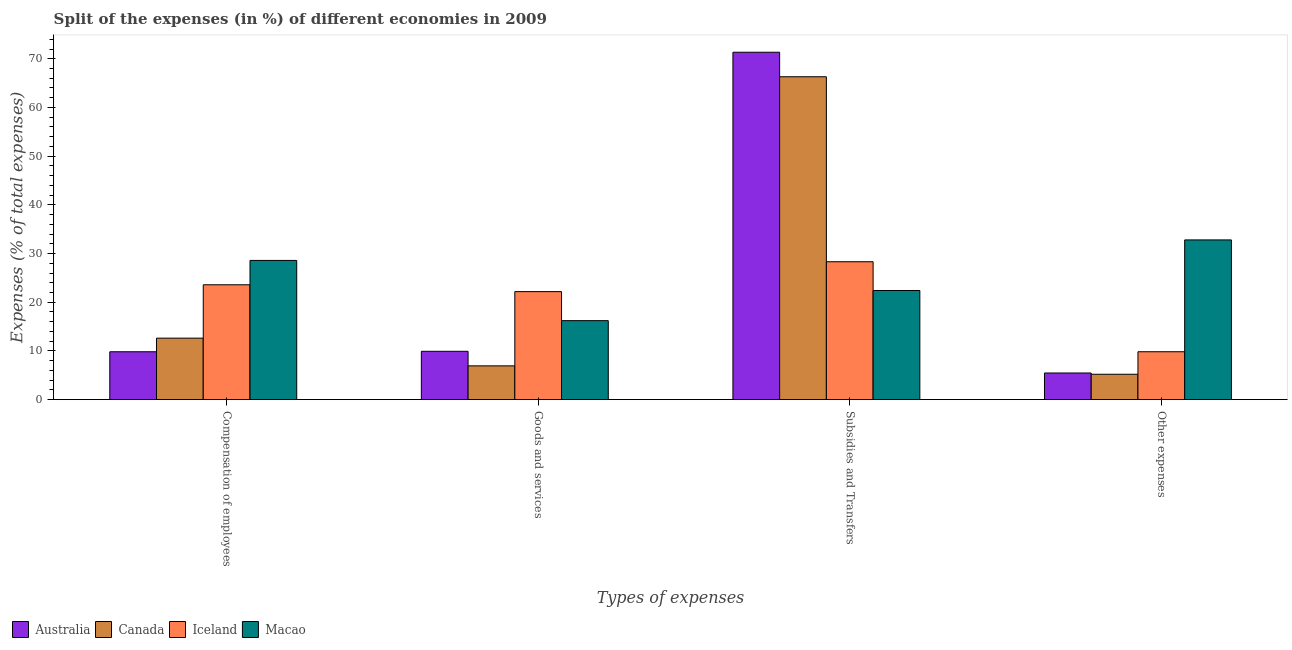How many different coloured bars are there?
Your answer should be very brief. 4. How many groups of bars are there?
Give a very brief answer. 4. Are the number of bars per tick equal to the number of legend labels?
Provide a short and direct response. Yes. Are the number of bars on each tick of the X-axis equal?
Provide a short and direct response. Yes. How many bars are there on the 2nd tick from the right?
Ensure brevity in your answer.  4. What is the label of the 4th group of bars from the left?
Provide a succinct answer. Other expenses. What is the percentage of amount spent on subsidies in Australia?
Offer a very short reply. 71.34. Across all countries, what is the maximum percentage of amount spent on compensation of employees?
Make the answer very short. 28.58. Across all countries, what is the minimum percentage of amount spent on subsidies?
Your answer should be very brief. 22.41. What is the total percentage of amount spent on other expenses in the graph?
Offer a very short reply. 53.3. What is the difference between the percentage of amount spent on goods and services in Iceland and that in Macao?
Provide a succinct answer. 5.96. What is the difference between the percentage of amount spent on compensation of employees in Iceland and the percentage of amount spent on other expenses in Macao?
Make the answer very short. -9.21. What is the average percentage of amount spent on compensation of employees per country?
Provide a short and direct response. 18.65. What is the difference between the percentage of amount spent on compensation of employees and percentage of amount spent on other expenses in Canada?
Keep it short and to the point. 7.42. In how many countries, is the percentage of amount spent on goods and services greater than 12 %?
Provide a short and direct response. 2. What is the ratio of the percentage of amount spent on other expenses in Canada to that in Australia?
Your response must be concise. 0.95. Is the percentage of amount spent on subsidies in Australia less than that in Canada?
Offer a terse response. No. Is the difference between the percentage of amount spent on compensation of employees in Iceland and Canada greater than the difference between the percentage of amount spent on other expenses in Iceland and Canada?
Give a very brief answer. Yes. What is the difference between the highest and the second highest percentage of amount spent on goods and services?
Provide a succinct answer. 5.96. What is the difference between the highest and the lowest percentage of amount spent on goods and services?
Provide a succinct answer. 15.25. In how many countries, is the percentage of amount spent on subsidies greater than the average percentage of amount spent on subsidies taken over all countries?
Make the answer very short. 2. Is it the case that in every country, the sum of the percentage of amount spent on compensation of employees and percentage of amount spent on subsidies is greater than the sum of percentage of amount spent on other expenses and percentage of amount spent on goods and services?
Ensure brevity in your answer.  Yes. Is it the case that in every country, the sum of the percentage of amount spent on compensation of employees and percentage of amount spent on goods and services is greater than the percentage of amount spent on subsidies?
Give a very brief answer. No. Are all the bars in the graph horizontal?
Give a very brief answer. No. Are the values on the major ticks of Y-axis written in scientific E-notation?
Make the answer very short. No. Does the graph contain grids?
Ensure brevity in your answer.  No. How many legend labels are there?
Keep it short and to the point. 4. What is the title of the graph?
Your answer should be very brief. Split of the expenses (in %) of different economies in 2009. What is the label or title of the X-axis?
Your response must be concise. Types of expenses. What is the label or title of the Y-axis?
Provide a short and direct response. Expenses (% of total expenses). What is the Expenses (% of total expenses) in Australia in Compensation of employees?
Ensure brevity in your answer.  9.83. What is the Expenses (% of total expenses) of Canada in Compensation of employees?
Keep it short and to the point. 12.62. What is the Expenses (% of total expenses) in Iceland in Compensation of employees?
Provide a short and direct response. 23.58. What is the Expenses (% of total expenses) in Macao in Compensation of employees?
Your answer should be very brief. 28.58. What is the Expenses (% of total expenses) of Australia in Goods and services?
Keep it short and to the point. 9.92. What is the Expenses (% of total expenses) of Canada in Goods and services?
Keep it short and to the point. 6.93. What is the Expenses (% of total expenses) in Iceland in Goods and services?
Offer a terse response. 22.18. What is the Expenses (% of total expenses) in Macao in Goods and services?
Provide a short and direct response. 16.21. What is the Expenses (% of total expenses) of Australia in Subsidies and Transfers?
Your answer should be compact. 71.34. What is the Expenses (% of total expenses) of Canada in Subsidies and Transfers?
Your answer should be compact. 66.3. What is the Expenses (% of total expenses) of Iceland in Subsidies and Transfers?
Your answer should be very brief. 28.31. What is the Expenses (% of total expenses) of Macao in Subsidies and Transfers?
Provide a short and direct response. 22.41. What is the Expenses (% of total expenses) in Australia in Other expenses?
Your response must be concise. 5.47. What is the Expenses (% of total expenses) in Canada in Other expenses?
Your answer should be very brief. 5.2. What is the Expenses (% of total expenses) of Iceland in Other expenses?
Your response must be concise. 9.83. What is the Expenses (% of total expenses) of Macao in Other expenses?
Your answer should be very brief. 32.8. Across all Types of expenses, what is the maximum Expenses (% of total expenses) in Australia?
Provide a succinct answer. 71.34. Across all Types of expenses, what is the maximum Expenses (% of total expenses) of Canada?
Keep it short and to the point. 66.3. Across all Types of expenses, what is the maximum Expenses (% of total expenses) of Iceland?
Offer a terse response. 28.31. Across all Types of expenses, what is the maximum Expenses (% of total expenses) of Macao?
Make the answer very short. 32.8. Across all Types of expenses, what is the minimum Expenses (% of total expenses) of Australia?
Keep it short and to the point. 5.47. Across all Types of expenses, what is the minimum Expenses (% of total expenses) of Canada?
Ensure brevity in your answer.  5.2. Across all Types of expenses, what is the minimum Expenses (% of total expenses) of Iceland?
Provide a short and direct response. 9.83. Across all Types of expenses, what is the minimum Expenses (% of total expenses) in Macao?
Ensure brevity in your answer.  16.21. What is the total Expenses (% of total expenses) in Australia in the graph?
Your response must be concise. 96.55. What is the total Expenses (% of total expenses) of Canada in the graph?
Your answer should be compact. 91.06. What is the total Expenses (% of total expenses) of Iceland in the graph?
Offer a very short reply. 83.91. What is the total Expenses (% of total expenses) in Macao in the graph?
Make the answer very short. 100. What is the difference between the Expenses (% of total expenses) in Australia in Compensation of employees and that in Goods and services?
Offer a terse response. -0.09. What is the difference between the Expenses (% of total expenses) of Canada in Compensation of employees and that in Goods and services?
Offer a terse response. 5.69. What is the difference between the Expenses (% of total expenses) of Iceland in Compensation of employees and that in Goods and services?
Make the answer very short. 1.41. What is the difference between the Expenses (% of total expenses) in Macao in Compensation of employees and that in Goods and services?
Offer a terse response. 12.37. What is the difference between the Expenses (% of total expenses) of Australia in Compensation of employees and that in Subsidies and Transfers?
Provide a short and direct response. -61.51. What is the difference between the Expenses (% of total expenses) in Canada in Compensation of employees and that in Subsidies and Transfers?
Your response must be concise. -53.68. What is the difference between the Expenses (% of total expenses) of Iceland in Compensation of employees and that in Subsidies and Transfers?
Provide a short and direct response. -4.73. What is the difference between the Expenses (% of total expenses) of Macao in Compensation of employees and that in Subsidies and Transfers?
Provide a short and direct response. 6.17. What is the difference between the Expenses (% of total expenses) of Australia in Compensation of employees and that in Other expenses?
Provide a succinct answer. 4.36. What is the difference between the Expenses (% of total expenses) of Canada in Compensation of employees and that in Other expenses?
Your answer should be compact. 7.42. What is the difference between the Expenses (% of total expenses) of Iceland in Compensation of employees and that in Other expenses?
Offer a very short reply. 13.75. What is the difference between the Expenses (% of total expenses) in Macao in Compensation of employees and that in Other expenses?
Provide a short and direct response. -4.21. What is the difference between the Expenses (% of total expenses) of Australia in Goods and services and that in Subsidies and Transfers?
Offer a very short reply. -61.42. What is the difference between the Expenses (% of total expenses) of Canada in Goods and services and that in Subsidies and Transfers?
Keep it short and to the point. -59.37. What is the difference between the Expenses (% of total expenses) of Iceland in Goods and services and that in Subsidies and Transfers?
Make the answer very short. -6.13. What is the difference between the Expenses (% of total expenses) in Macao in Goods and services and that in Subsidies and Transfers?
Offer a very short reply. -6.19. What is the difference between the Expenses (% of total expenses) in Australia in Goods and services and that in Other expenses?
Keep it short and to the point. 4.45. What is the difference between the Expenses (% of total expenses) in Canada in Goods and services and that in Other expenses?
Offer a very short reply. 1.73. What is the difference between the Expenses (% of total expenses) in Iceland in Goods and services and that in Other expenses?
Ensure brevity in your answer.  12.35. What is the difference between the Expenses (% of total expenses) in Macao in Goods and services and that in Other expenses?
Make the answer very short. -16.58. What is the difference between the Expenses (% of total expenses) in Australia in Subsidies and Transfers and that in Other expenses?
Offer a terse response. 65.87. What is the difference between the Expenses (% of total expenses) of Canada in Subsidies and Transfers and that in Other expenses?
Make the answer very short. 61.1. What is the difference between the Expenses (% of total expenses) of Iceland in Subsidies and Transfers and that in Other expenses?
Your answer should be very brief. 18.48. What is the difference between the Expenses (% of total expenses) of Macao in Subsidies and Transfers and that in Other expenses?
Give a very brief answer. -10.39. What is the difference between the Expenses (% of total expenses) in Australia in Compensation of employees and the Expenses (% of total expenses) in Canada in Goods and services?
Ensure brevity in your answer.  2.9. What is the difference between the Expenses (% of total expenses) in Australia in Compensation of employees and the Expenses (% of total expenses) in Iceland in Goods and services?
Give a very brief answer. -12.35. What is the difference between the Expenses (% of total expenses) in Australia in Compensation of employees and the Expenses (% of total expenses) in Macao in Goods and services?
Offer a very short reply. -6.39. What is the difference between the Expenses (% of total expenses) of Canada in Compensation of employees and the Expenses (% of total expenses) of Iceland in Goods and services?
Provide a succinct answer. -9.56. What is the difference between the Expenses (% of total expenses) in Canada in Compensation of employees and the Expenses (% of total expenses) in Macao in Goods and services?
Give a very brief answer. -3.59. What is the difference between the Expenses (% of total expenses) of Iceland in Compensation of employees and the Expenses (% of total expenses) of Macao in Goods and services?
Keep it short and to the point. 7.37. What is the difference between the Expenses (% of total expenses) in Australia in Compensation of employees and the Expenses (% of total expenses) in Canada in Subsidies and Transfers?
Offer a very short reply. -56.48. What is the difference between the Expenses (% of total expenses) in Australia in Compensation of employees and the Expenses (% of total expenses) in Iceland in Subsidies and Transfers?
Keep it short and to the point. -18.49. What is the difference between the Expenses (% of total expenses) in Australia in Compensation of employees and the Expenses (% of total expenses) in Macao in Subsidies and Transfers?
Your response must be concise. -12.58. What is the difference between the Expenses (% of total expenses) in Canada in Compensation of employees and the Expenses (% of total expenses) in Iceland in Subsidies and Transfers?
Provide a short and direct response. -15.69. What is the difference between the Expenses (% of total expenses) in Canada in Compensation of employees and the Expenses (% of total expenses) in Macao in Subsidies and Transfers?
Give a very brief answer. -9.79. What is the difference between the Expenses (% of total expenses) of Iceland in Compensation of employees and the Expenses (% of total expenses) of Macao in Subsidies and Transfers?
Your answer should be compact. 1.18. What is the difference between the Expenses (% of total expenses) in Australia in Compensation of employees and the Expenses (% of total expenses) in Canada in Other expenses?
Give a very brief answer. 4.62. What is the difference between the Expenses (% of total expenses) of Australia in Compensation of employees and the Expenses (% of total expenses) of Iceland in Other expenses?
Ensure brevity in your answer.  -0. What is the difference between the Expenses (% of total expenses) in Australia in Compensation of employees and the Expenses (% of total expenses) in Macao in Other expenses?
Offer a very short reply. -22.97. What is the difference between the Expenses (% of total expenses) of Canada in Compensation of employees and the Expenses (% of total expenses) of Iceland in Other expenses?
Ensure brevity in your answer.  2.79. What is the difference between the Expenses (% of total expenses) in Canada in Compensation of employees and the Expenses (% of total expenses) in Macao in Other expenses?
Provide a short and direct response. -20.17. What is the difference between the Expenses (% of total expenses) of Iceland in Compensation of employees and the Expenses (% of total expenses) of Macao in Other expenses?
Offer a very short reply. -9.21. What is the difference between the Expenses (% of total expenses) in Australia in Goods and services and the Expenses (% of total expenses) in Canada in Subsidies and Transfers?
Provide a short and direct response. -56.39. What is the difference between the Expenses (% of total expenses) in Australia in Goods and services and the Expenses (% of total expenses) in Iceland in Subsidies and Transfers?
Your answer should be compact. -18.39. What is the difference between the Expenses (% of total expenses) in Australia in Goods and services and the Expenses (% of total expenses) in Macao in Subsidies and Transfers?
Offer a very short reply. -12.49. What is the difference between the Expenses (% of total expenses) of Canada in Goods and services and the Expenses (% of total expenses) of Iceland in Subsidies and Transfers?
Keep it short and to the point. -21.38. What is the difference between the Expenses (% of total expenses) in Canada in Goods and services and the Expenses (% of total expenses) in Macao in Subsidies and Transfers?
Give a very brief answer. -15.48. What is the difference between the Expenses (% of total expenses) of Iceland in Goods and services and the Expenses (% of total expenses) of Macao in Subsidies and Transfers?
Your answer should be compact. -0.23. What is the difference between the Expenses (% of total expenses) in Australia in Goods and services and the Expenses (% of total expenses) in Canada in Other expenses?
Your answer should be compact. 4.71. What is the difference between the Expenses (% of total expenses) of Australia in Goods and services and the Expenses (% of total expenses) of Iceland in Other expenses?
Your answer should be compact. 0.09. What is the difference between the Expenses (% of total expenses) in Australia in Goods and services and the Expenses (% of total expenses) in Macao in Other expenses?
Offer a very short reply. -22.88. What is the difference between the Expenses (% of total expenses) of Canada in Goods and services and the Expenses (% of total expenses) of Iceland in Other expenses?
Offer a very short reply. -2.9. What is the difference between the Expenses (% of total expenses) of Canada in Goods and services and the Expenses (% of total expenses) of Macao in Other expenses?
Provide a succinct answer. -25.86. What is the difference between the Expenses (% of total expenses) in Iceland in Goods and services and the Expenses (% of total expenses) in Macao in Other expenses?
Make the answer very short. -10.62. What is the difference between the Expenses (% of total expenses) in Australia in Subsidies and Transfers and the Expenses (% of total expenses) in Canada in Other expenses?
Your answer should be very brief. 66.13. What is the difference between the Expenses (% of total expenses) of Australia in Subsidies and Transfers and the Expenses (% of total expenses) of Iceland in Other expenses?
Give a very brief answer. 61.51. What is the difference between the Expenses (% of total expenses) in Australia in Subsidies and Transfers and the Expenses (% of total expenses) in Macao in Other expenses?
Offer a terse response. 38.54. What is the difference between the Expenses (% of total expenses) in Canada in Subsidies and Transfers and the Expenses (% of total expenses) in Iceland in Other expenses?
Your response must be concise. 56.47. What is the difference between the Expenses (% of total expenses) of Canada in Subsidies and Transfers and the Expenses (% of total expenses) of Macao in Other expenses?
Your answer should be compact. 33.51. What is the difference between the Expenses (% of total expenses) of Iceland in Subsidies and Transfers and the Expenses (% of total expenses) of Macao in Other expenses?
Your response must be concise. -4.48. What is the average Expenses (% of total expenses) of Australia per Types of expenses?
Give a very brief answer. 24.14. What is the average Expenses (% of total expenses) of Canada per Types of expenses?
Provide a succinct answer. 22.77. What is the average Expenses (% of total expenses) of Iceland per Types of expenses?
Offer a terse response. 20.98. What is the difference between the Expenses (% of total expenses) of Australia and Expenses (% of total expenses) of Canada in Compensation of employees?
Provide a succinct answer. -2.79. What is the difference between the Expenses (% of total expenses) of Australia and Expenses (% of total expenses) of Iceland in Compensation of employees?
Your response must be concise. -13.76. What is the difference between the Expenses (% of total expenses) in Australia and Expenses (% of total expenses) in Macao in Compensation of employees?
Your answer should be very brief. -18.75. What is the difference between the Expenses (% of total expenses) of Canada and Expenses (% of total expenses) of Iceland in Compensation of employees?
Ensure brevity in your answer.  -10.96. What is the difference between the Expenses (% of total expenses) in Canada and Expenses (% of total expenses) in Macao in Compensation of employees?
Provide a succinct answer. -15.96. What is the difference between the Expenses (% of total expenses) in Iceland and Expenses (% of total expenses) in Macao in Compensation of employees?
Your response must be concise. -5. What is the difference between the Expenses (% of total expenses) in Australia and Expenses (% of total expenses) in Canada in Goods and services?
Keep it short and to the point. 2.99. What is the difference between the Expenses (% of total expenses) in Australia and Expenses (% of total expenses) in Iceland in Goods and services?
Offer a very short reply. -12.26. What is the difference between the Expenses (% of total expenses) in Australia and Expenses (% of total expenses) in Macao in Goods and services?
Provide a succinct answer. -6.3. What is the difference between the Expenses (% of total expenses) of Canada and Expenses (% of total expenses) of Iceland in Goods and services?
Make the answer very short. -15.25. What is the difference between the Expenses (% of total expenses) of Canada and Expenses (% of total expenses) of Macao in Goods and services?
Offer a very short reply. -9.28. What is the difference between the Expenses (% of total expenses) in Iceland and Expenses (% of total expenses) in Macao in Goods and services?
Give a very brief answer. 5.96. What is the difference between the Expenses (% of total expenses) of Australia and Expenses (% of total expenses) of Canada in Subsidies and Transfers?
Offer a terse response. 5.03. What is the difference between the Expenses (% of total expenses) of Australia and Expenses (% of total expenses) of Iceland in Subsidies and Transfers?
Provide a succinct answer. 43.03. What is the difference between the Expenses (% of total expenses) of Australia and Expenses (% of total expenses) of Macao in Subsidies and Transfers?
Ensure brevity in your answer.  48.93. What is the difference between the Expenses (% of total expenses) of Canada and Expenses (% of total expenses) of Iceland in Subsidies and Transfers?
Make the answer very short. 37.99. What is the difference between the Expenses (% of total expenses) in Canada and Expenses (% of total expenses) in Macao in Subsidies and Transfers?
Keep it short and to the point. 43.9. What is the difference between the Expenses (% of total expenses) in Iceland and Expenses (% of total expenses) in Macao in Subsidies and Transfers?
Provide a short and direct response. 5.91. What is the difference between the Expenses (% of total expenses) of Australia and Expenses (% of total expenses) of Canada in Other expenses?
Provide a succinct answer. 0.26. What is the difference between the Expenses (% of total expenses) of Australia and Expenses (% of total expenses) of Iceland in Other expenses?
Offer a terse response. -4.36. What is the difference between the Expenses (% of total expenses) of Australia and Expenses (% of total expenses) of Macao in Other expenses?
Provide a short and direct response. -27.33. What is the difference between the Expenses (% of total expenses) of Canada and Expenses (% of total expenses) of Iceland in Other expenses?
Your answer should be compact. -4.63. What is the difference between the Expenses (% of total expenses) in Canada and Expenses (% of total expenses) in Macao in Other expenses?
Offer a terse response. -27.59. What is the difference between the Expenses (% of total expenses) in Iceland and Expenses (% of total expenses) in Macao in Other expenses?
Your answer should be very brief. -22.97. What is the ratio of the Expenses (% of total expenses) in Canada in Compensation of employees to that in Goods and services?
Offer a very short reply. 1.82. What is the ratio of the Expenses (% of total expenses) in Iceland in Compensation of employees to that in Goods and services?
Provide a succinct answer. 1.06. What is the ratio of the Expenses (% of total expenses) in Macao in Compensation of employees to that in Goods and services?
Ensure brevity in your answer.  1.76. What is the ratio of the Expenses (% of total expenses) in Australia in Compensation of employees to that in Subsidies and Transfers?
Ensure brevity in your answer.  0.14. What is the ratio of the Expenses (% of total expenses) in Canada in Compensation of employees to that in Subsidies and Transfers?
Your response must be concise. 0.19. What is the ratio of the Expenses (% of total expenses) of Iceland in Compensation of employees to that in Subsidies and Transfers?
Keep it short and to the point. 0.83. What is the ratio of the Expenses (% of total expenses) in Macao in Compensation of employees to that in Subsidies and Transfers?
Your answer should be very brief. 1.28. What is the ratio of the Expenses (% of total expenses) of Australia in Compensation of employees to that in Other expenses?
Provide a short and direct response. 1.8. What is the ratio of the Expenses (% of total expenses) of Canada in Compensation of employees to that in Other expenses?
Provide a succinct answer. 2.42. What is the ratio of the Expenses (% of total expenses) in Iceland in Compensation of employees to that in Other expenses?
Offer a very short reply. 2.4. What is the ratio of the Expenses (% of total expenses) in Macao in Compensation of employees to that in Other expenses?
Provide a succinct answer. 0.87. What is the ratio of the Expenses (% of total expenses) of Australia in Goods and services to that in Subsidies and Transfers?
Provide a succinct answer. 0.14. What is the ratio of the Expenses (% of total expenses) of Canada in Goods and services to that in Subsidies and Transfers?
Offer a very short reply. 0.1. What is the ratio of the Expenses (% of total expenses) in Iceland in Goods and services to that in Subsidies and Transfers?
Provide a succinct answer. 0.78. What is the ratio of the Expenses (% of total expenses) in Macao in Goods and services to that in Subsidies and Transfers?
Provide a short and direct response. 0.72. What is the ratio of the Expenses (% of total expenses) in Australia in Goods and services to that in Other expenses?
Offer a terse response. 1.81. What is the ratio of the Expenses (% of total expenses) in Canada in Goods and services to that in Other expenses?
Keep it short and to the point. 1.33. What is the ratio of the Expenses (% of total expenses) in Iceland in Goods and services to that in Other expenses?
Give a very brief answer. 2.26. What is the ratio of the Expenses (% of total expenses) of Macao in Goods and services to that in Other expenses?
Your answer should be very brief. 0.49. What is the ratio of the Expenses (% of total expenses) in Australia in Subsidies and Transfers to that in Other expenses?
Your response must be concise. 13.05. What is the ratio of the Expenses (% of total expenses) of Canada in Subsidies and Transfers to that in Other expenses?
Provide a short and direct response. 12.74. What is the ratio of the Expenses (% of total expenses) in Iceland in Subsidies and Transfers to that in Other expenses?
Make the answer very short. 2.88. What is the ratio of the Expenses (% of total expenses) of Macao in Subsidies and Transfers to that in Other expenses?
Provide a succinct answer. 0.68. What is the difference between the highest and the second highest Expenses (% of total expenses) of Australia?
Keep it short and to the point. 61.42. What is the difference between the highest and the second highest Expenses (% of total expenses) in Canada?
Offer a terse response. 53.68. What is the difference between the highest and the second highest Expenses (% of total expenses) of Iceland?
Provide a succinct answer. 4.73. What is the difference between the highest and the second highest Expenses (% of total expenses) in Macao?
Offer a very short reply. 4.21. What is the difference between the highest and the lowest Expenses (% of total expenses) in Australia?
Keep it short and to the point. 65.87. What is the difference between the highest and the lowest Expenses (% of total expenses) of Canada?
Provide a short and direct response. 61.1. What is the difference between the highest and the lowest Expenses (% of total expenses) in Iceland?
Your answer should be compact. 18.48. What is the difference between the highest and the lowest Expenses (% of total expenses) of Macao?
Provide a succinct answer. 16.58. 